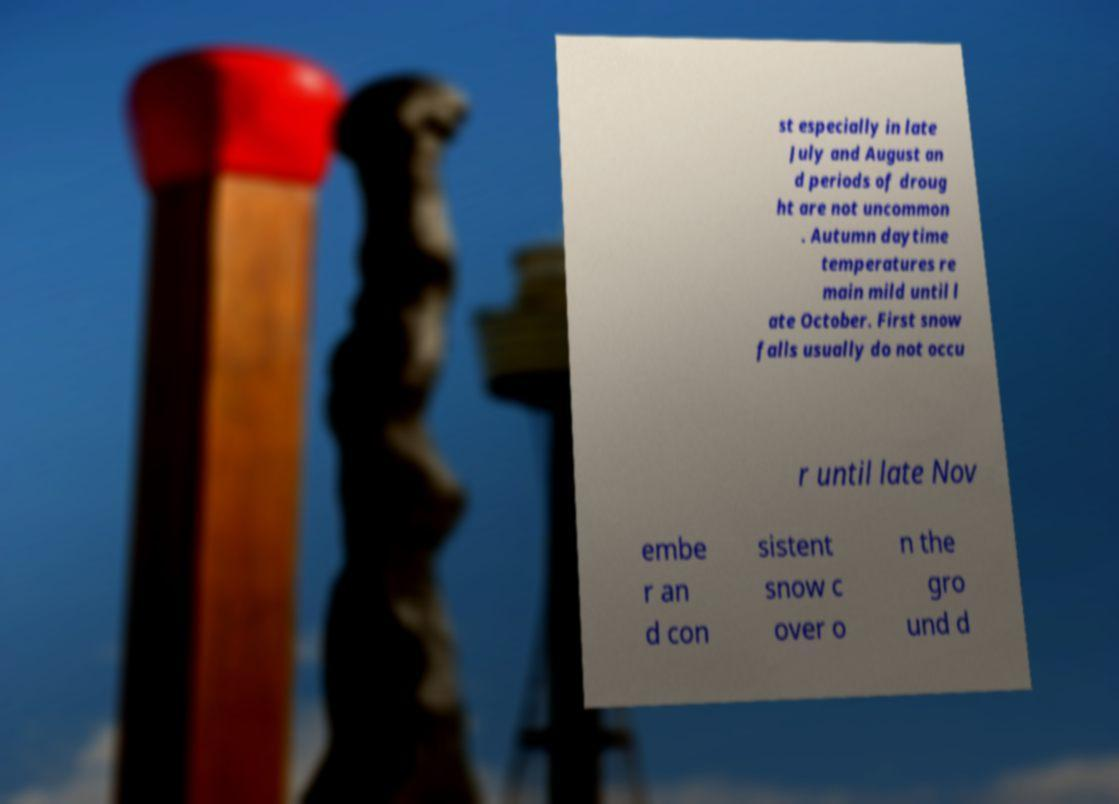What messages or text are displayed in this image? I need them in a readable, typed format. st especially in late July and August an d periods of droug ht are not uncommon . Autumn daytime temperatures re main mild until l ate October. First snow falls usually do not occu r until late Nov embe r an d con sistent snow c over o n the gro und d 